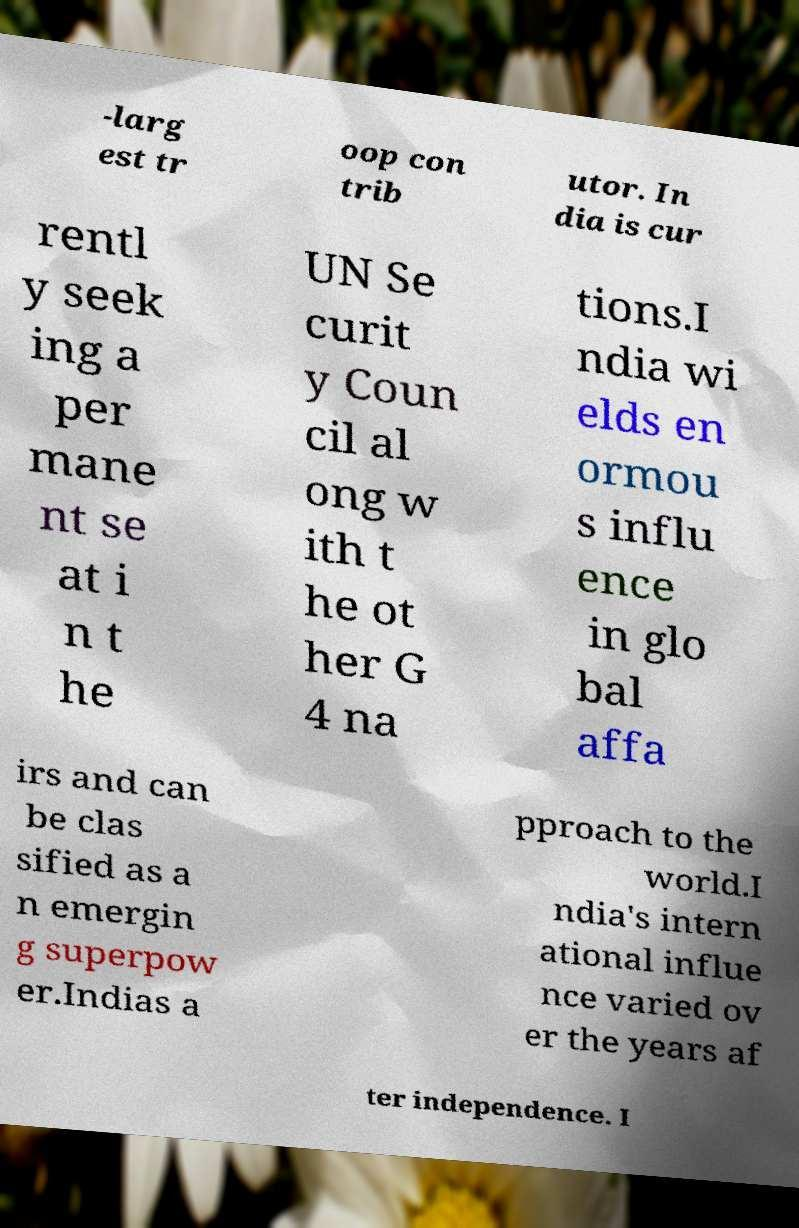Please read and relay the text visible in this image. What does it say? -larg est tr oop con trib utor. In dia is cur rentl y seek ing a per mane nt se at i n t he UN Se curit y Coun cil al ong w ith t he ot her G 4 na tions.I ndia wi elds en ormou s influ ence in glo bal affa irs and can be clas sified as a n emergin g superpow er.Indias a pproach to the world.I ndia's intern ational influe nce varied ov er the years af ter independence. I 